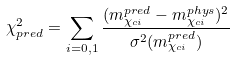<formula> <loc_0><loc_0><loc_500><loc_500>\chi ^ { 2 } _ { p r e d } = \sum _ { i = 0 , 1 } \frac { ( m ^ { p r e d } _ { \chi _ { c i } } - m ^ { p h y s } _ { \chi _ { c i } } ) ^ { 2 } } { \sigma ^ { 2 } ( m ^ { p r e d } _ { \chi _ { c i } } ) }</formula> 